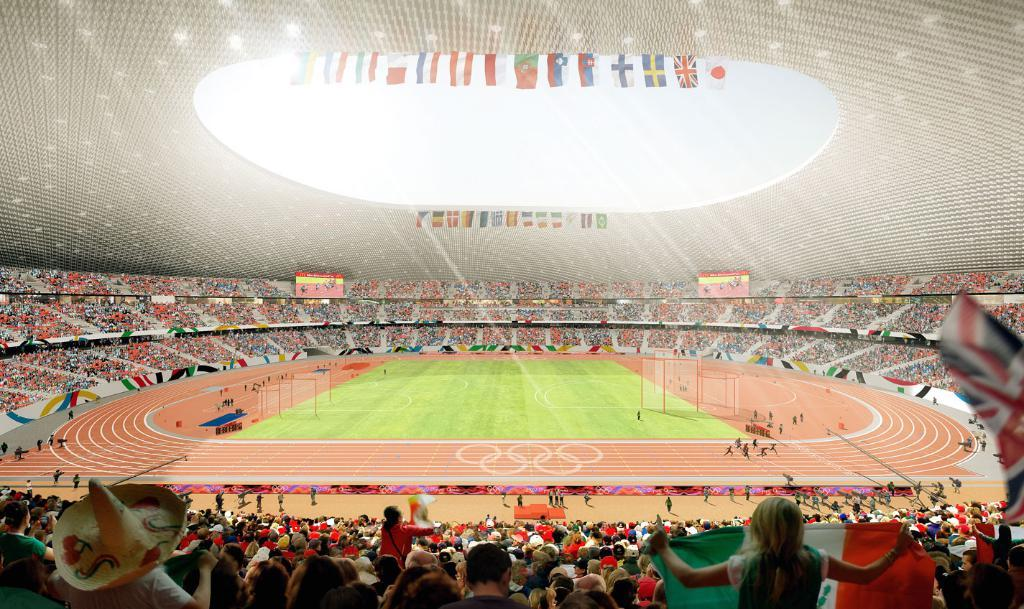What is the main structure visible in the image? There is a stadium in the image. What are the people in the stadium doing? There are groups of people sitting in the stadium, and some people are playing in the ground within the stadium. What type of lumber is being used to construct the stadium in the image? There is no mention of lumber or construction materials in the image, as it only shows the stadium and people inside it. 